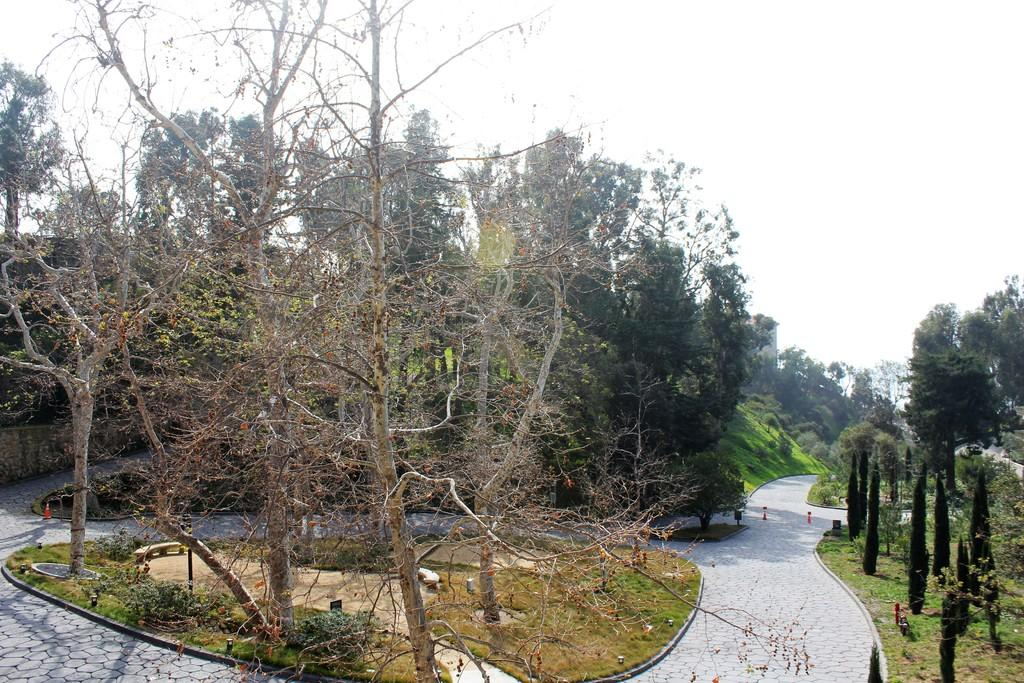What type of natural elements can be seen in the image? There are trees in the image. What objects are present on the road in the image? There are traffic cones and boards on the road. What is visible at the top of the image? The sky is visible at the top of the image. What type of sticks are being used in the industry depicted in the image? There is no industry or sticks present in the image; it features trees, traffic cones, and boards on the road. What color is the silver object in the image? There is no silver object present in the image. 